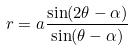Convert formula to latex. <formula><loc_0><loc_0><loc_500><loc_500>r = a \frac { \sin ( 2 \theta - \alpha ) } { \sin ( \theta - \alpha ) }</formula> 